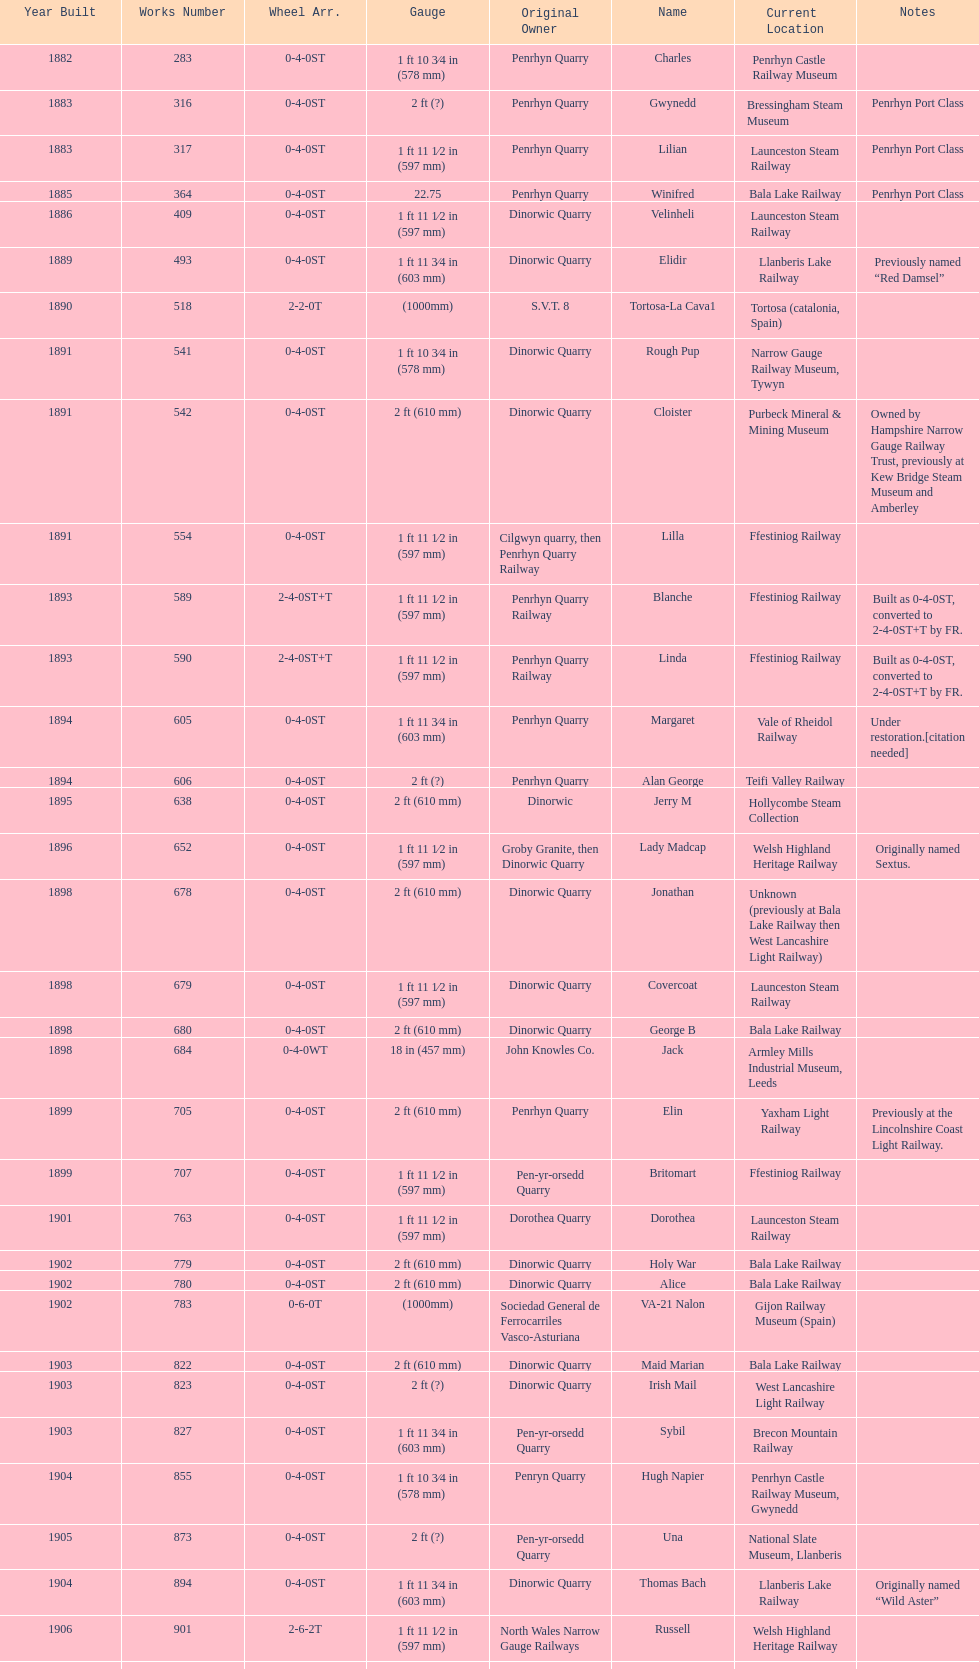In which year was the peak production of steam locomotives achieved? 1898. 